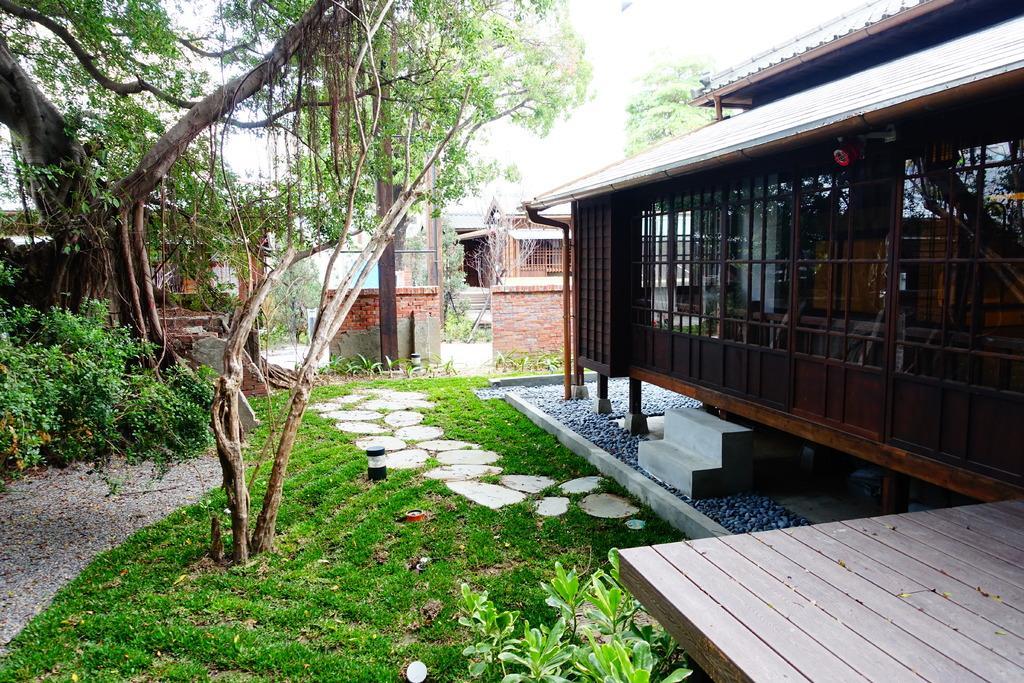Describe this image in one or two sentences. Land is covered with grass. Here we can see plants and trees. Houses with glass windows. 